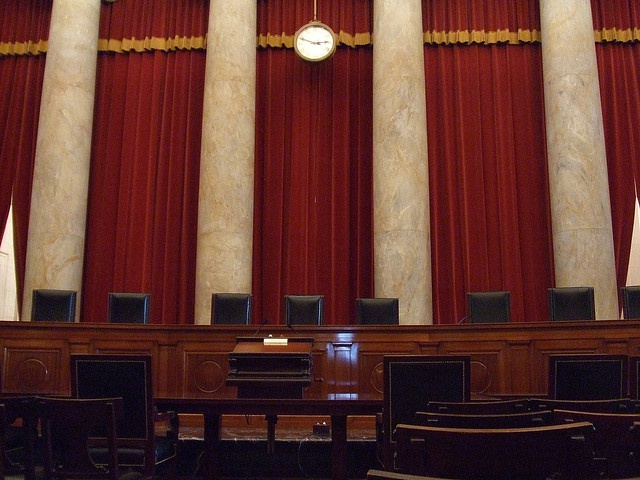Describe the objects in this image and their specific colors. I can see chair in maroon, black, and brown tones, chair in maroon, black, and gray tones, chair in maroon, black, and brown tones, chair in maroon, black, and gray tones, and chair in maroon and black tones in this image. 